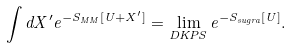Convert formula to latex. <formula><loc_0><loc_0><loc_500><loc_500>\int d X ^ { \prime } e ^ { - S _ { M M } [ U + X ^ { \prime } ] } = \lim _ { D K P S } e ^ { - S _ { s u g r a } [ U ] } .</formula> 